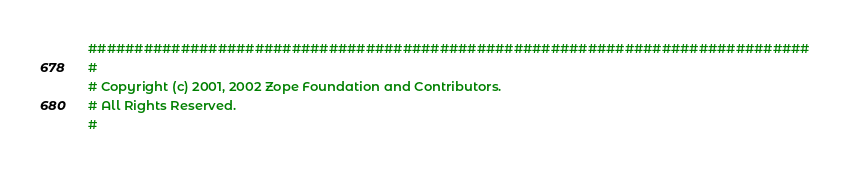Convert code to text. <code><loc_0><loc_0><loc_500><loc_500><_Python_>##############################################################################
#
# Copyright (c) 2001, 2002 Zope Foundation and Contributors.
# All Rights Reserved.
#</code> 